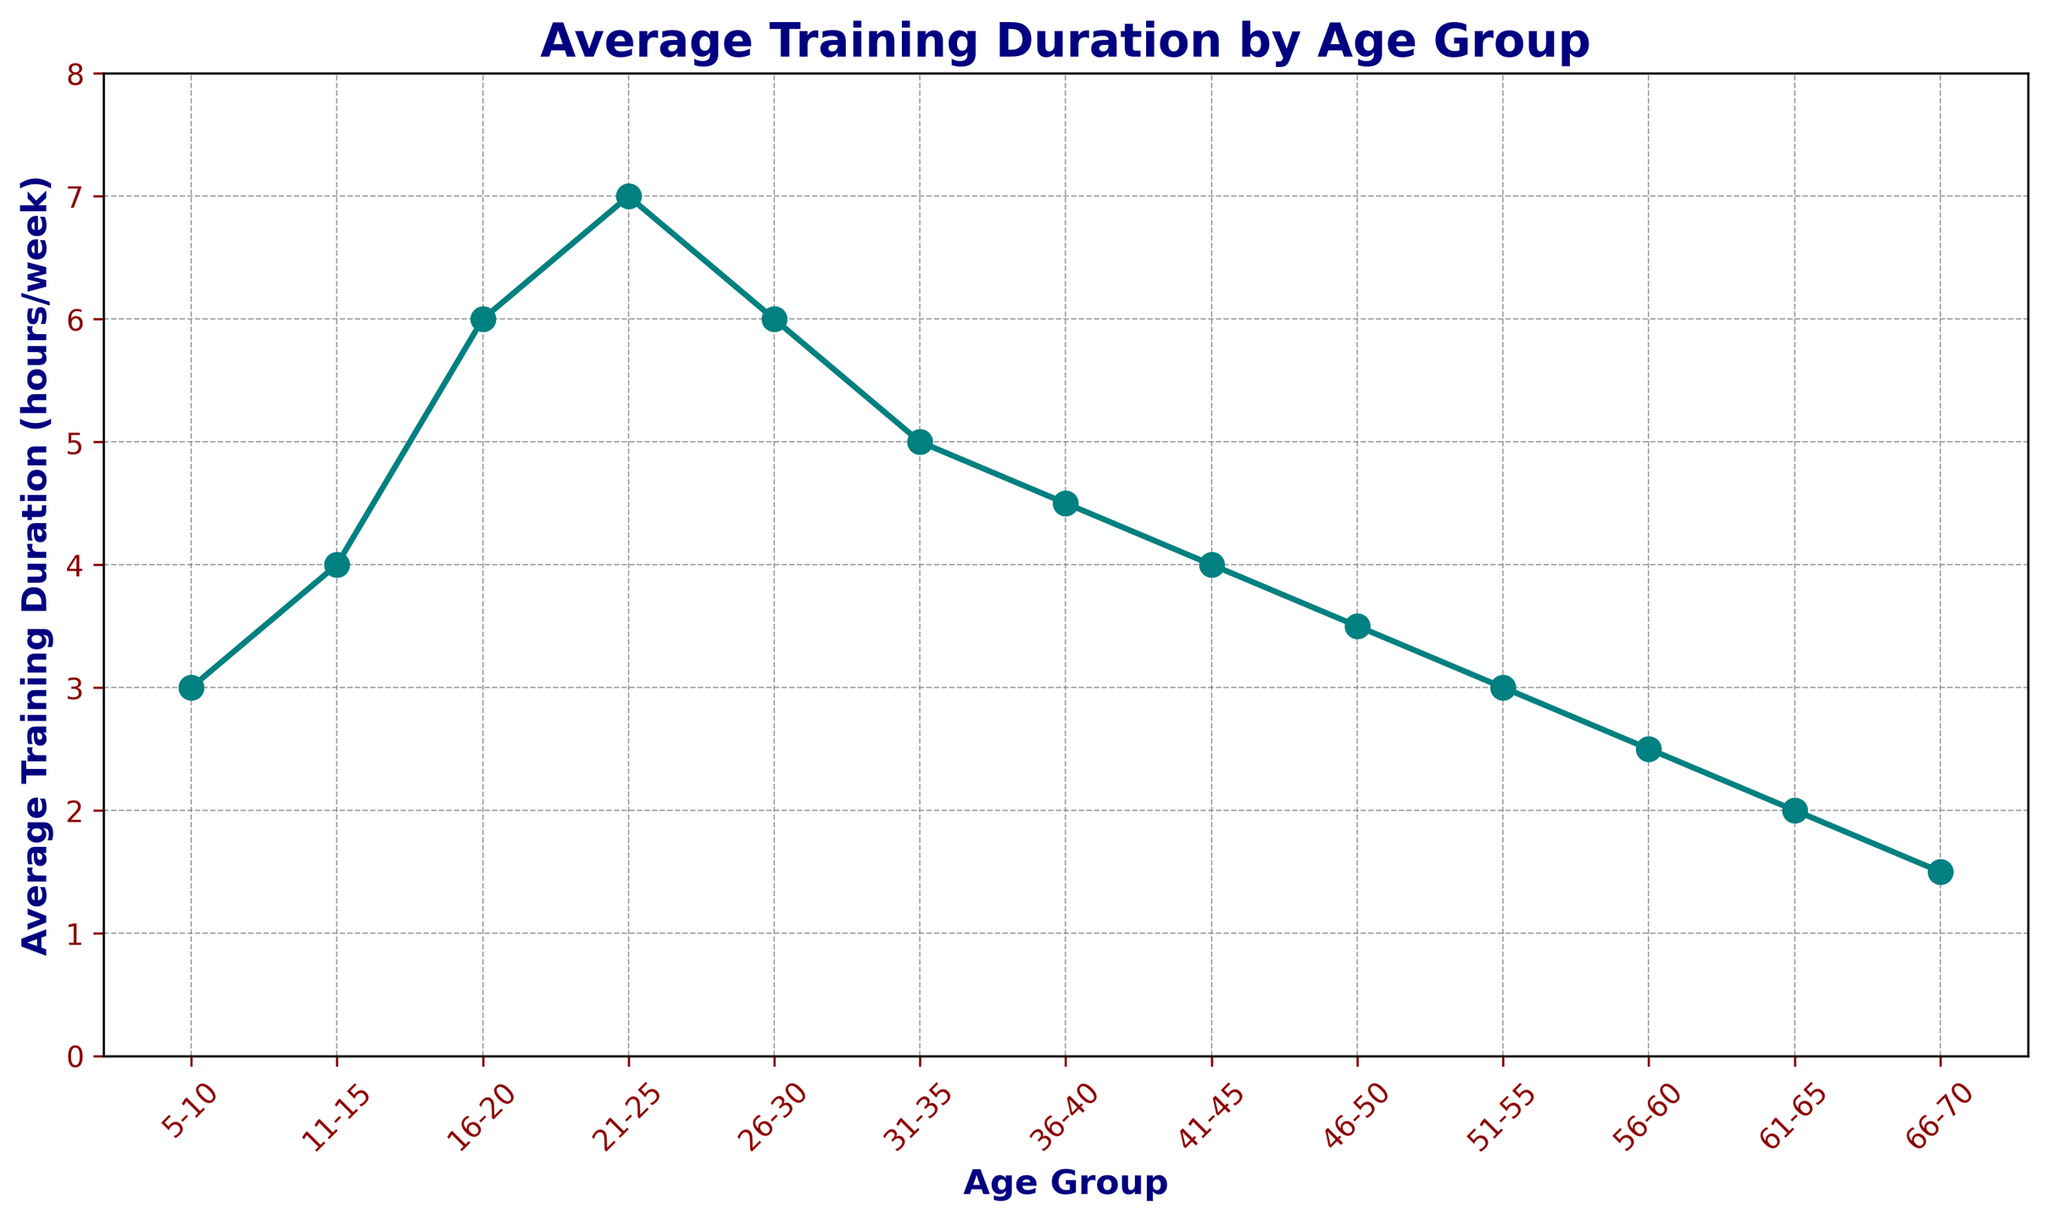What's the highest average training duration across all age groups? The highest point in the line chart represents the peak value. According to the data, the age group 21-25 has the highest average training duration of 7 hours per week.
Answer: 7 hours per week What is the average training duration for age groups 16-20 and 26-30 combined? Sum the average training duration for both age groups and then divide by 2. (6 hours/week for 16-20 + 6 hours/week for 26-30) / 2 = 6 hours/week.
Answer: 6 hours per week Which age group has a higher average training duration: 11-15 or 41-45? Compare the values directly from the chart. The average training duration for the 11-15 age group is 4 hours/week, while for the 41-45 age group, it is 4 hours/week. Therefore, both are equal.
Answer: Equal What's the difference between the highest and the lowest average training durations? Subtract the lowest average training duration from the highest. The highest is 7 hours/week for 21-25, and the lowest is 1.5 hours/week for 66-70. The difference is 7 - 1.5 = 5.5 hours/week.
Answer: 5.5 hours/week For age groups 56-60 and 61-65, what is their combined average training duration? Add the average training durations for 56-60 and 61-65. 2.5 hours/week for 56-60 + 2 hours/week for 61-65 = 4.5 hours/week combined.
Answer: 4.5 hours/week Which age group shows the sharpest decline in average training duration? Look for the steepest drop in the line chart. The steepest decline appears between the age groups 51-55 (3 hours/week) and 56-60 (2.5 hours/week) with a drop of 0.5 hours/week.
Answer: 51-55 to 56-60 How does the average training duration for age groups 31-35 and 46-50 compare? Compare the values directly from the chart. The average training duration for 31-35 is 5 hours/week, and for 46-50, it is 3.5 hours/week. So, 31-35 is higher.
Answer: 31-35 What is the change in average training duration from age group 26-30 to 36-40? Find the difference between the two values. The average training duration is 6 hours/week for 26-30 and 4.5 hours/week for 36-40. The change is 6 - 4.5 = 1.5 hours/week.
Answer: 1.5 hours/week What is the sum of average training durations for the youngest and oldest age groups? Add the average training durations for 5-10 and 66-70. 3 hours/week for 5-10 + 1.5 hours/week for 66-70 = 4.5 hours/week total.
Answer: 4.5 hours per week 